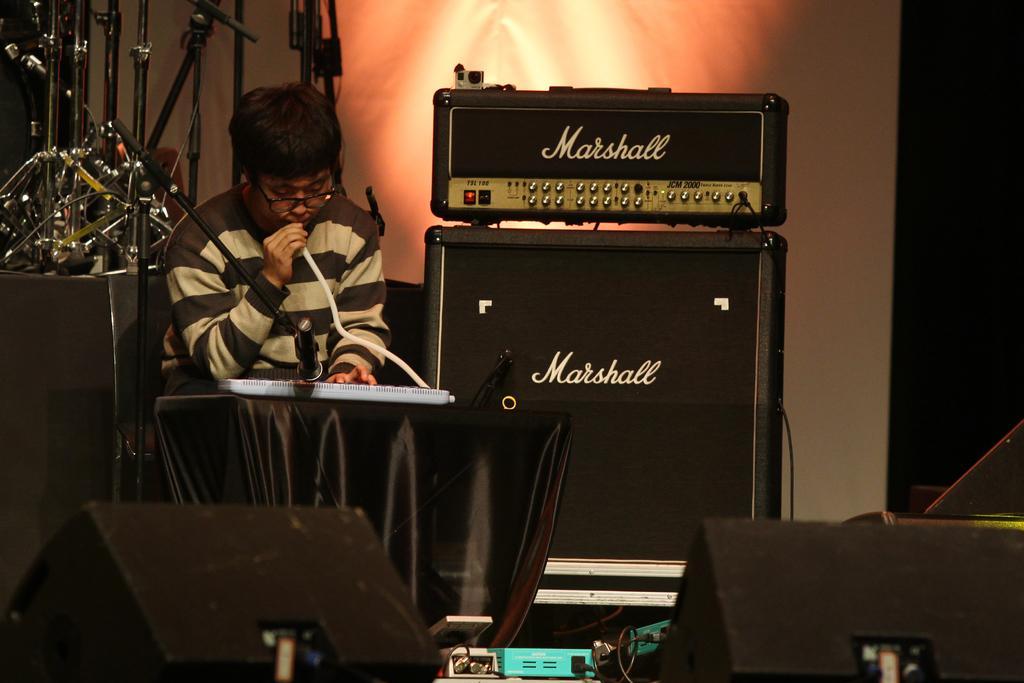How would you summarize this image in a sentence or two? In this image there is a person holding a pipe. Before him there is a table having a musical instrument. Left side there is a mike stand. Behind him there is a table having few stands on it. Bottom of the image there are few objects. Beside him there are few devices. Background there is a wall. 